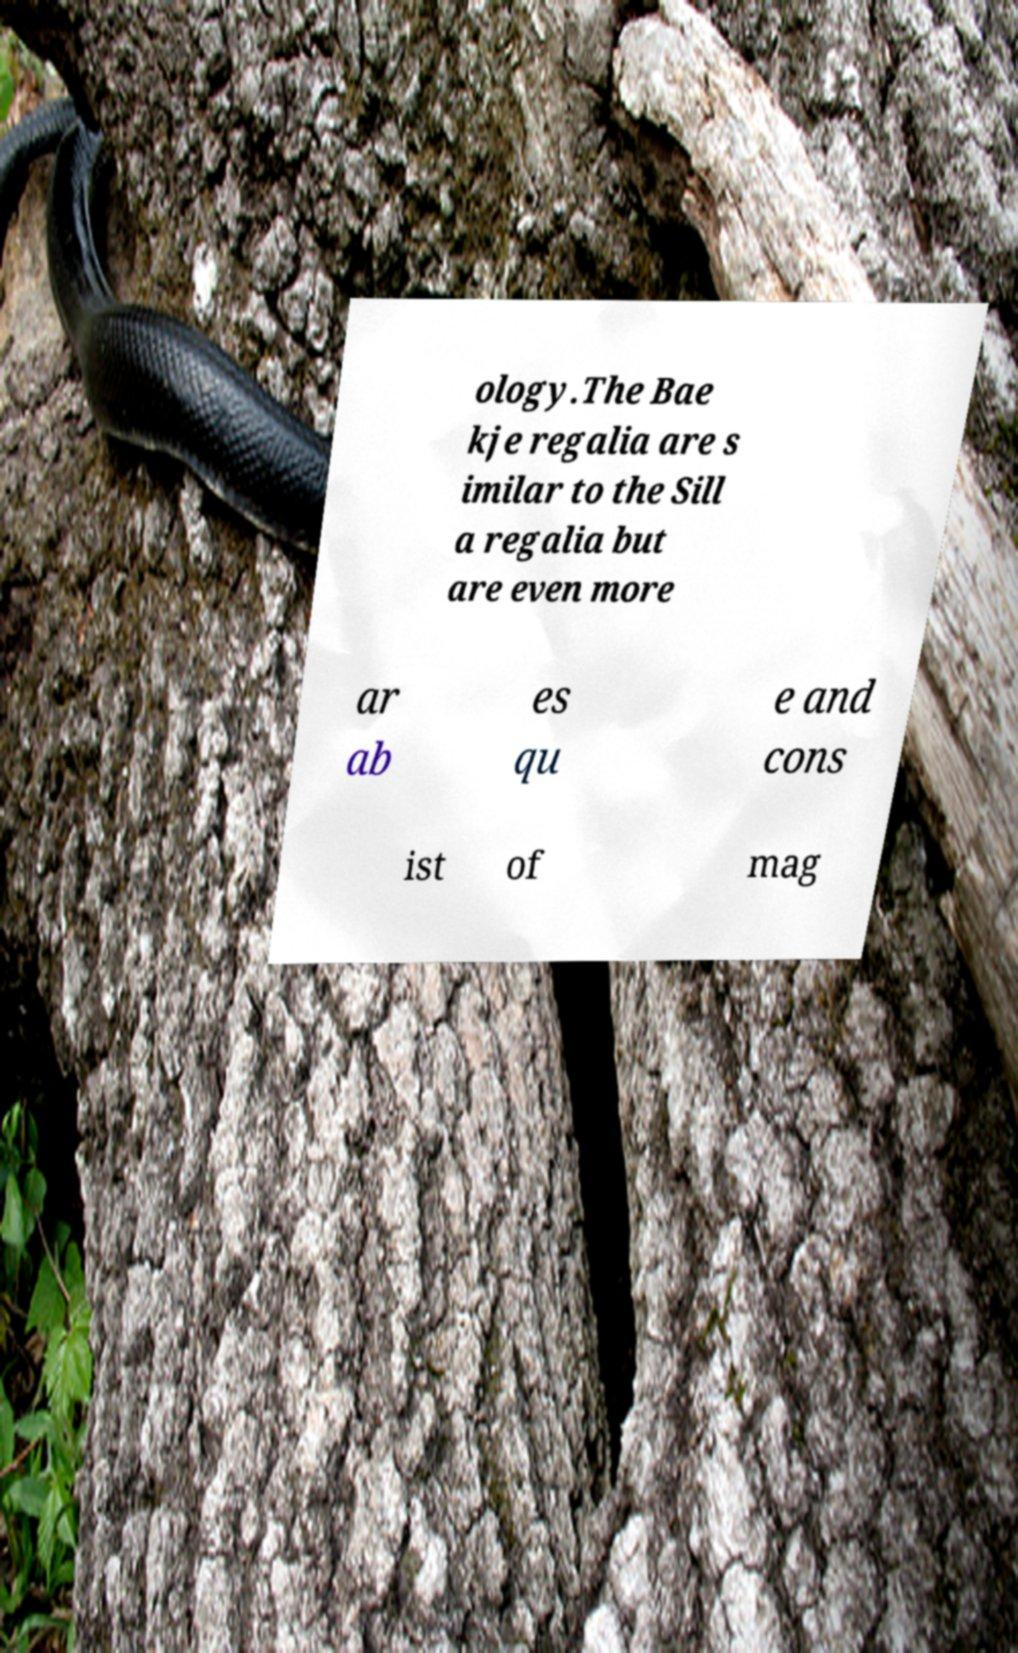Could you extract and type out the text from this image? ology.The Bae kje regalia are s imilar to the Sill a regalia but are even more ar ab es qu e and cons ist of mag 